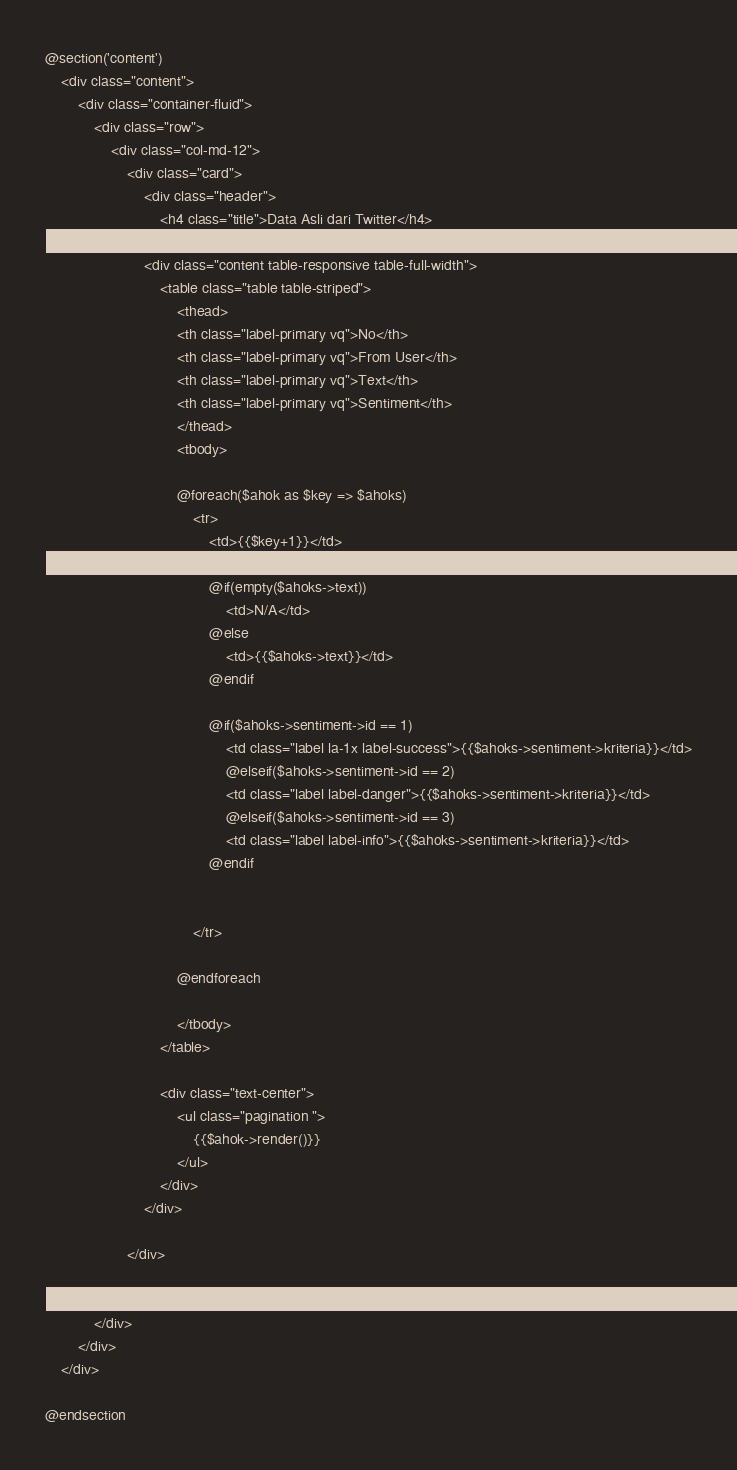<code> <loc_0><loc_0><loc_500><loc_500><_PHP_>
@section('content')
    <div class="content">
        <div class="container-fluid">
            <div class="row">
                <div class="col-md-12">
                    <div class="card">
                        <div class="header">
                            <h4 class="title">Data Asli dari Twitter</h4>
                        </div>
                        <div class="content table-responsive table-full-width">
                            <table class="table table-striped">
                                <thead>
                                <th class="label-primary vq">No</th>
                                <th class="label-primary vq">From User</th>
                                <th class="label-primary vq">Text</th>
                                <th class="label-primary vq">Sentiment</th>
                                </thead>
                                <tbody>

                                @foreach($ahok as $key => $ahoks)
                                    <tr>
                                        <td>{{$key+1}}</td>
                                        <td>{{$ahoks->From_User}}</td>
                                        @if(empty($ahoks->text))
                                            <td>N/A</td>
                                        @else
                                            <td>{{$ahoks->text}}</td>
                                        @endif

                                        @if($ahoks->sentiment->id == 1)
                                            <td class="label la-1x label-success">{{$ahoks->sentiment->kriteria}}</td>
                                            @elseif($ahoks->sentiment->id == 2)
                                            <td class="label label-danger">{{$ahoks->sentiment->kriteria}}</td>
                                            @elseif($ahoks->sentiment->id == 3)
                                            <td class="label label-info">{{$ahoks->sentiment->kriteria}}</td>
                                        @endif


                                    </tr>

                                @endforeach

                                </tbody>
                            </table>

                            <div class="text-center">
                                <ul class="pagination ">
                                    {{$ahok->render()}}
                                </ul>
                            </div>
                        </div>

                    </div>

                </div>
            </div>
        </div>
    </div>

@endsection</code> 